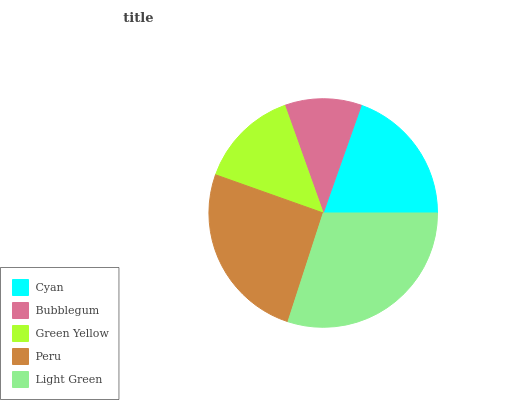Is Bubblegum the minimum?
Answer yes or no. Yes. Is Light Green the maximum?
Answer yes or no. Yes. Is Green Yellow the minimum?
Answer yes or no. No. Is Green Yellow the maximum?
Answer yes or no. No. Is Green Yellow greater than Bubblegum?
Answer yes or no. Yes. Is Bubblegum less than Green Yellow?
Answer yes or no. Yes. Is Bubblegum greater than Green Yellow?
Answer yes or no. No. Is Green Yellow less than Bubblegum?
Answer yes or no. No. Is Cyan the high median?
Answer yes or no. Yes. Is Cyan the low median?
Answer yes or no. Yes. Is Peru the high median?
Answer yes or no. No. Is Bubblegum the low median?
Answer yes or no. No. 